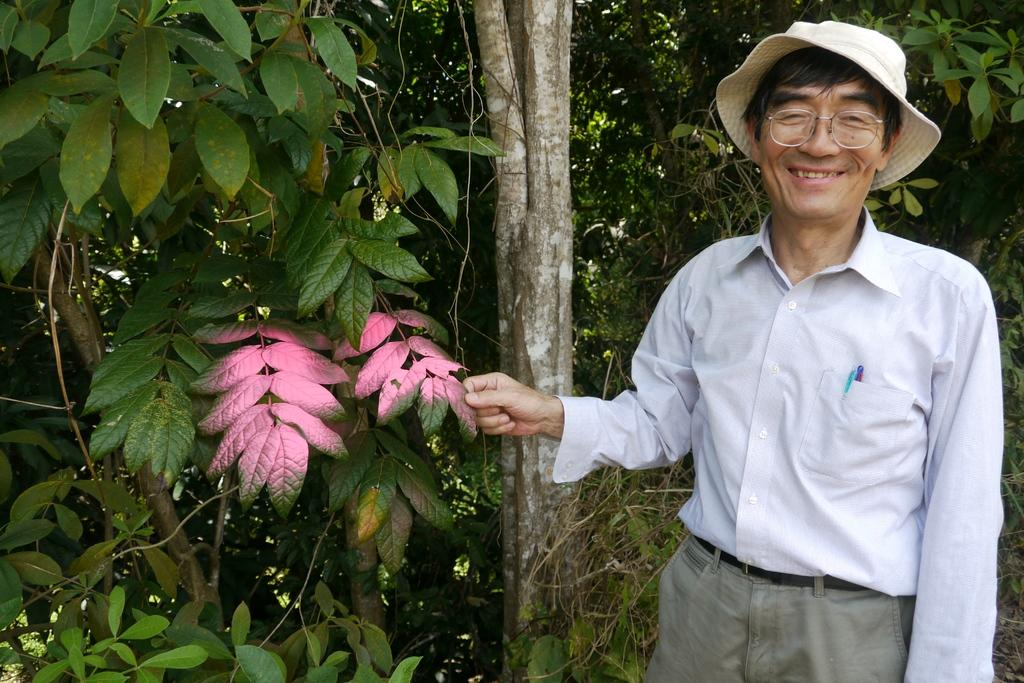What is the person in the image doing? The person is standing in the image. What is the person holding in the image? The person is holding a leaf in the image. What is the person wearing in the image? The person is wearing a white and ash-colored dress and a cap in the image. What type of vegetation can be seen in the image? There are green trees and pink leaves in the image. What is the person's reason for wearing a boot in the image? There is no boot mentioned or visible in the image. 